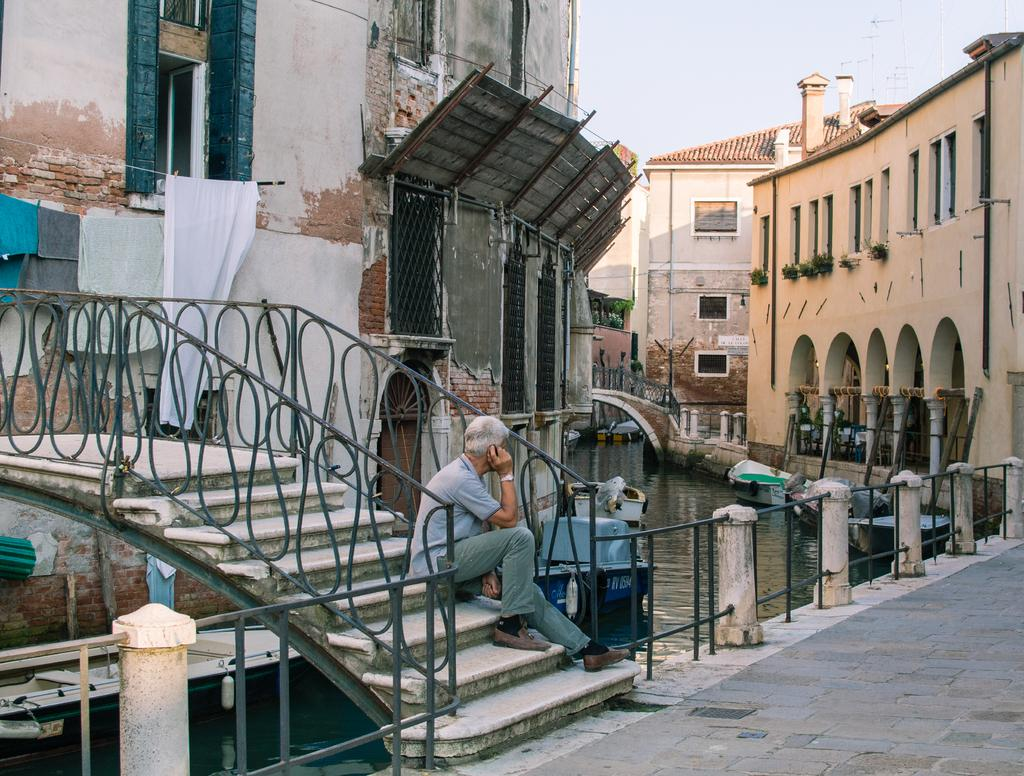What is the man in the image doing? The man is sitting in the image. What can be seen near the man? There are railings and steps in the image. What is visible above the water in the image? Boats are visible above the water in the image. What items are present in the image related to personal belongings? Clothes are present in the image. What structures are visible in the image? Poles and buildings are visible in the image. What is visible in the background of the image? The sky is visible in the background of the image. What type of stage can be seen in the image? There is no stage present in the image. What kind of test is being conducted in the image? There is no test being conducted in the image. 